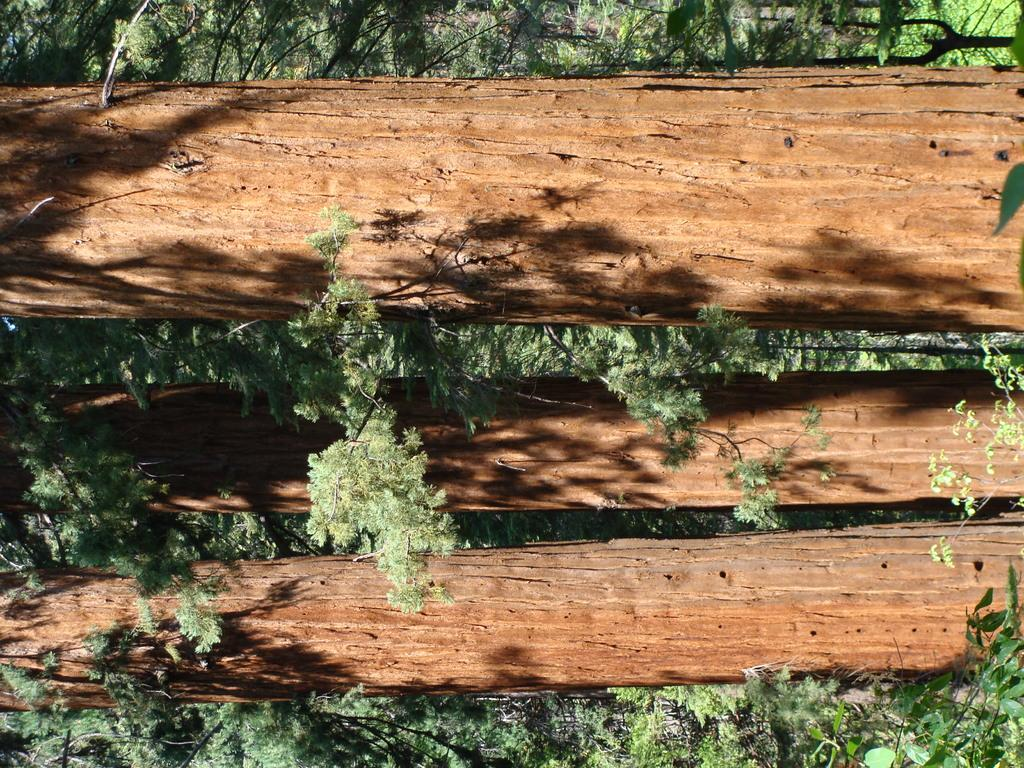What type of living organisms can be seen in the image? Plants can be seen in the image. What material are some of the objects made of in the image? There are wooden planks in the image. What type of brake system is installed on the plants in the image? There is no brake system present in the image, as the image features plants and wooden planks. 